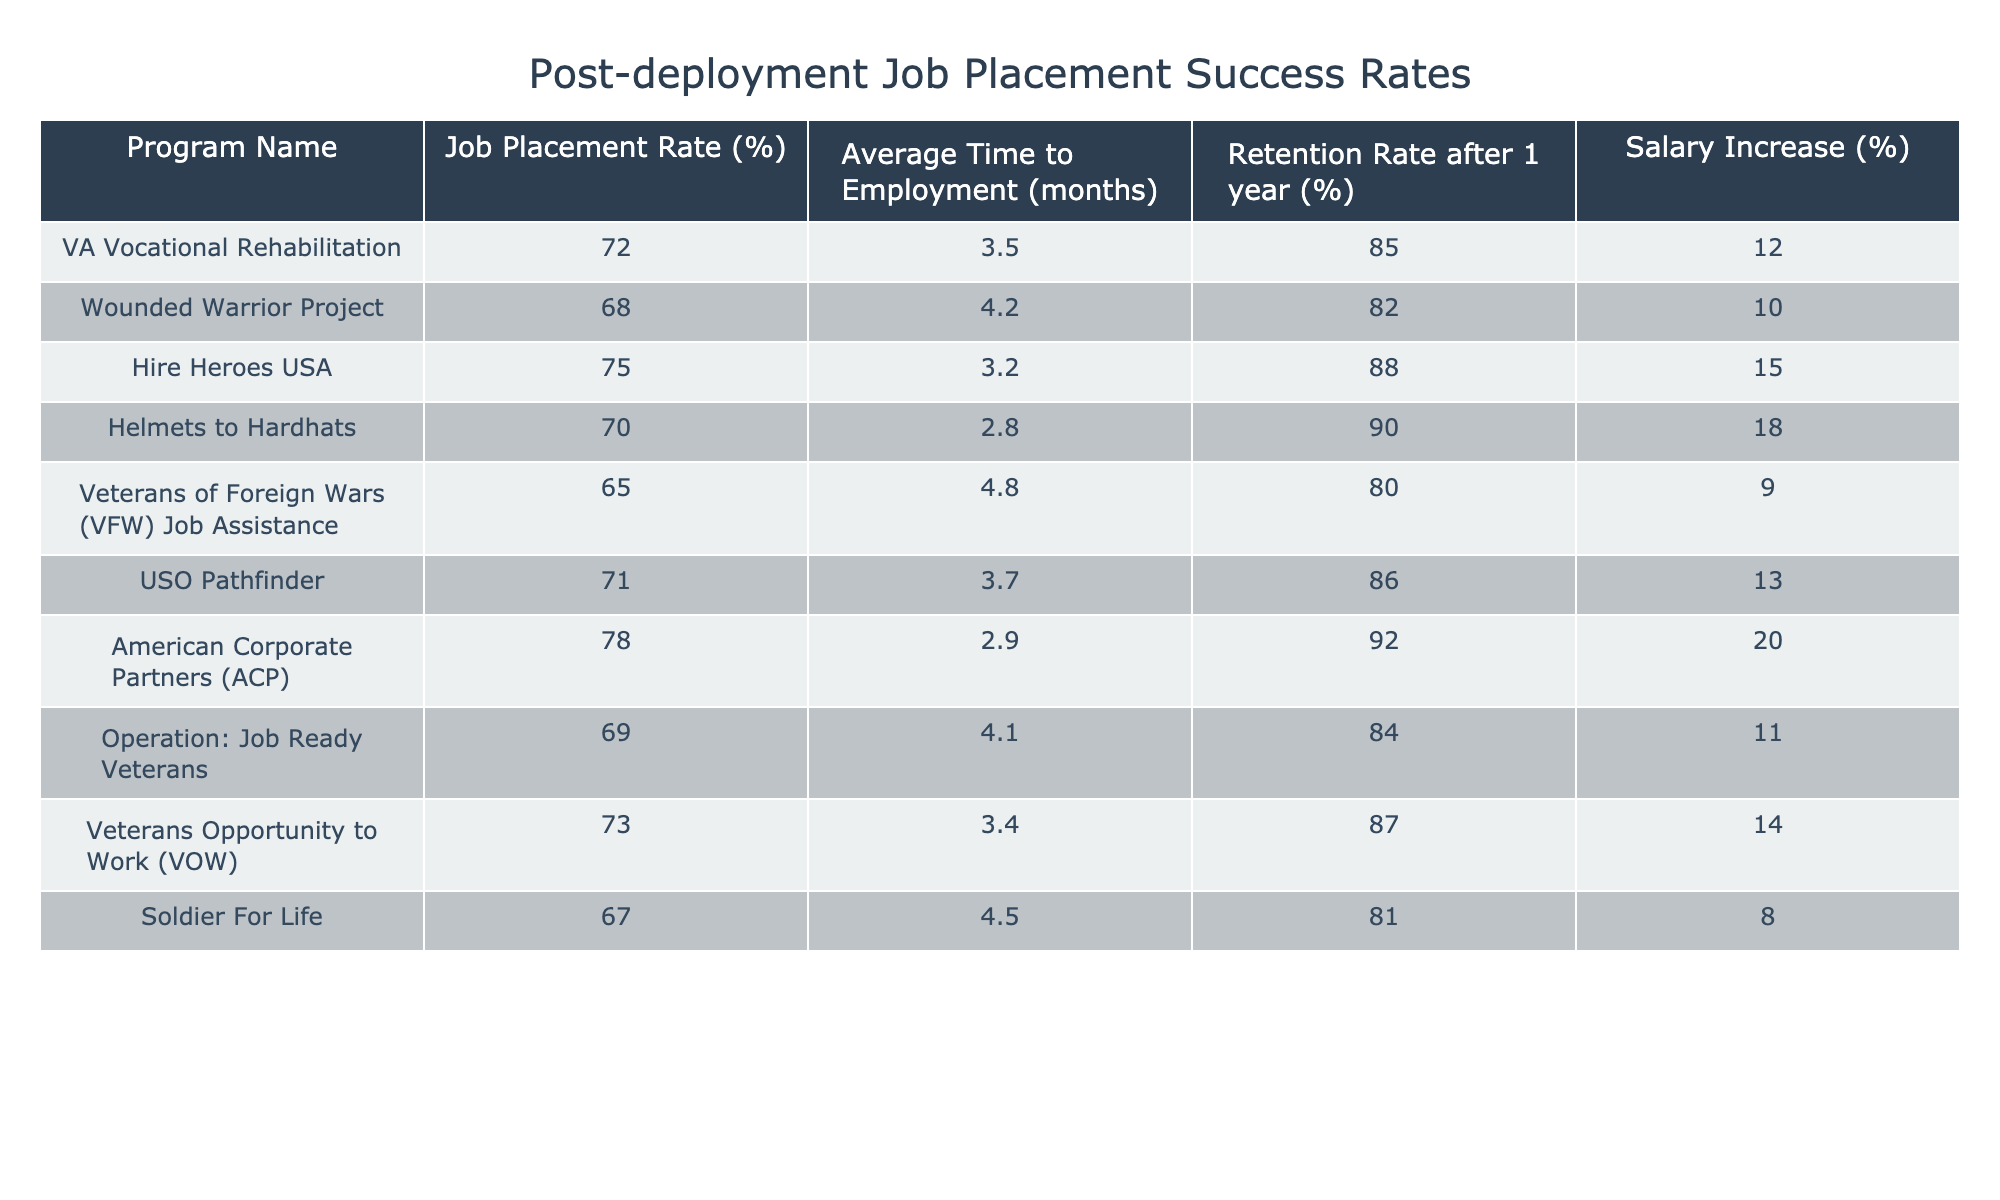What is the job placement rate for Hire Heroes USA? The table shows that the job placement rate for Hire Heroes USA is specified clearly under the "Job Placement Rate (%)" column, where it indicates 75%.
Answer: 75% Which program has the highest retention rate after 1 year? The retention rates after 1 year for all programs are listed in the table. Only American Corporate Partners (ACP) has the highest rate at 92%.
Answer: 92% What is the average time to employment for the program with the lowest job placement rate? The program with the lowest job placement rate is Veterans of Foreign Wars (VFW) Job Assistance at 65%. The average time to employment for this program, as shown in the table, is 4.8 months.
Answer: 4.8 months Is there any program with a salary increase of 20%? Looking at the "Salary Increase (%)" column, only the American Corporate Partners (ACP) program has a salary increase of 20%, confirming that yes, there is such a program.
Answer: Yes What is the difference in job placement rates between the highest and lowest performing programs? The highest job placement rate is 78% from American Corporate Partners (ACP) and the lowest is 65% from Veterans of Foreign Wars (VFW) Job Assistance. The difference is 78% - 65% = 13%.
Answer: 13% How many programs have a job placement rate above 70%? By reviewing the job placement rates of each program, we see that the following programs exceed 70%: Hire Heroes USA (75%), American Corporate Partners (ACP) (78%), and VA Vocational Rehabilitation (72%). This counts to a total of 3 programs.
Answer: 3 What is the average salary increase of programs with a job placement rate below 70%? The programs below 70% are Wounded Warrior Project (10%), Veterans of Foreign Wars (VFW) Job Assistance (9%), and Soldier For Life (8%). Summing these increases gives (10 + 9 + 8 = 27%), and the average is 27% / 3 = 9%.
Answer: 9% Among the programs, which has the shortest average time to employment? The average time to employment is the lowest for Helmets to Hardhats at 2.8 months, making it the program with the shortest duration.
Answer: 2.8 months What is the average retention rate for programs with a job placement rate of 70% or higher? The retention rates for programs with above 70% are: Hire Heroes USA (88%), American Corporate Partners (92%), VA Vocational Rehabilitation (85%), and USO Pathfinder (86%). The average is (88 + 92 + 85 + 86) / 4 = 87.75%.
Answer: 87.75% Among all programs, which has the longest average time to employment? By analyzing the "Average Time to Employment (months)" column, Veterans of Foreign Wars (VFW) Job Assistance has the longest time at 4.8 months.
Answer: 4.8 months 